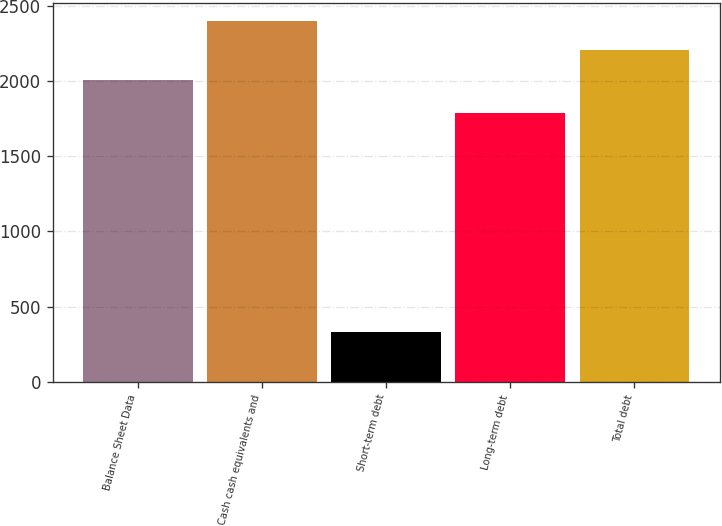Convert chart. <chart><loc_0><loc_0><loc_500><loc_500><bar_chart><fcel>Balance Sheet Data<fcel>Cash cash equivalents and<fcel>Short-term debt<fcel>Long-term debt<fcel>Total debt<nl><fcel>2008<fcel>2396.42<fcel>332.8<fcel>1786.9<fcel>2202.21<nl></chart> 